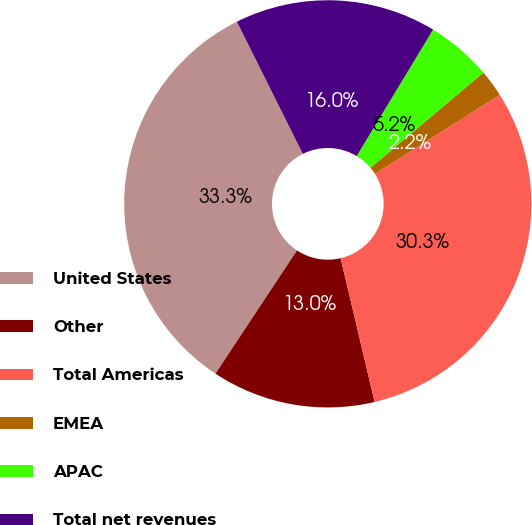Convert chart. <chart><loc_0><loc_0><loc_500><loc_500><pie_chart><fcel>United States<fcel>Other<fcel>Total Americas<fcel>EMEA<fcel>APAC<fcel>Total net revenues<nl><fcel>33.33%<fcel>12.99%<fcel>30.3%<fcel>2.16%<fcel>5.19%<fcel>16.02%<nl></chart> 